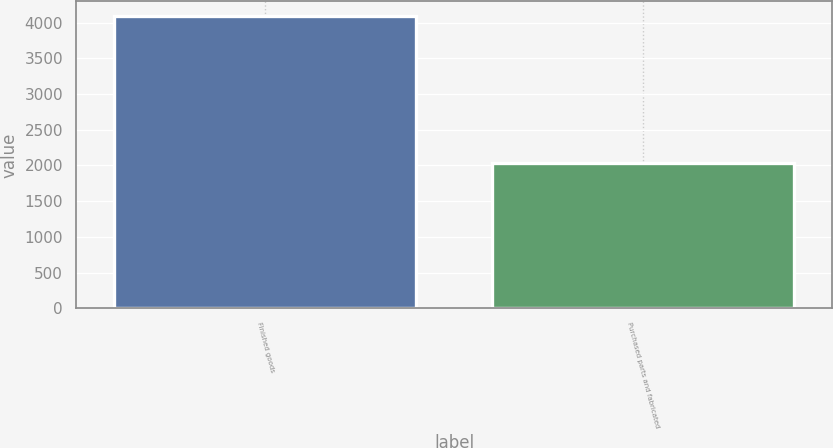Convert chart to OTSL. <chart><loc_0><loc_0><loc_500><loc_500><bar_chart><fcel>Finished goods<fcel>Purchased parts and fabricated<nl><fcel>4092<fcel>2036<nl></chart> 